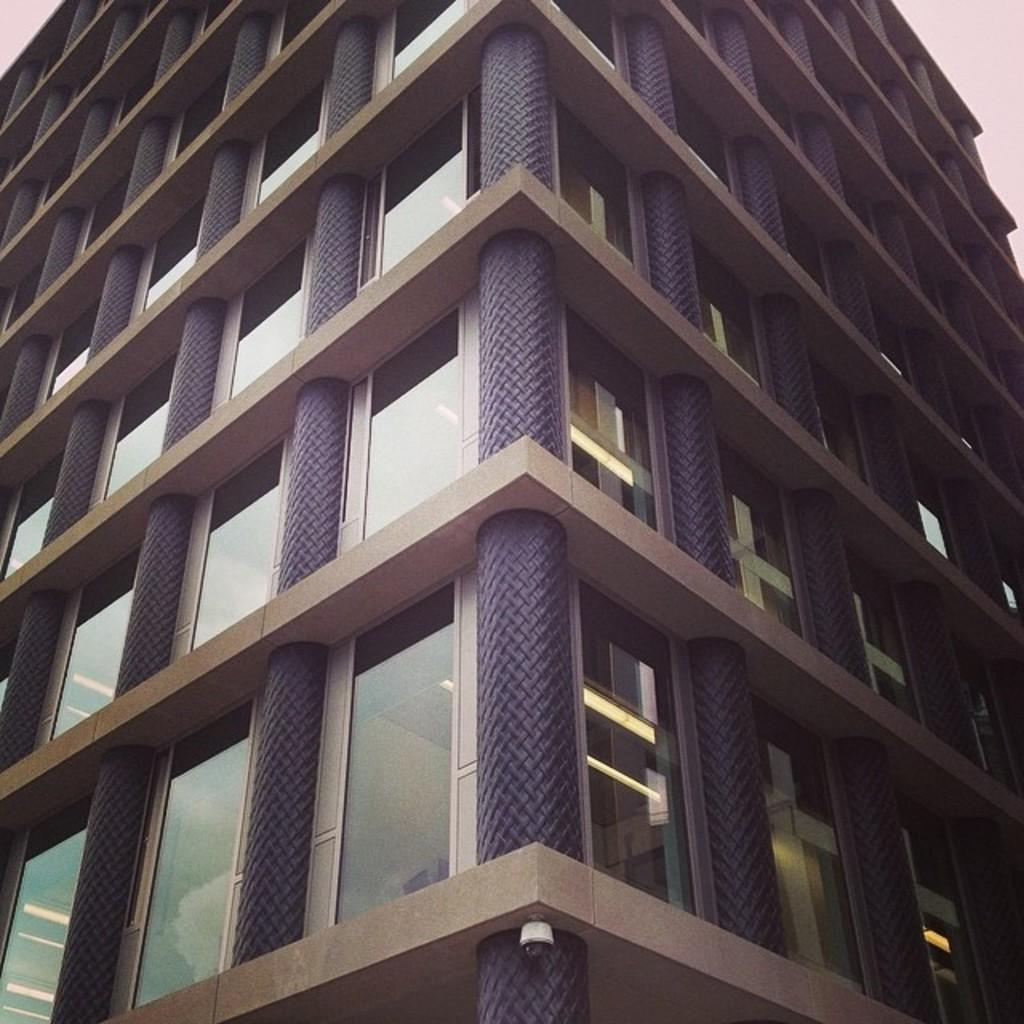What type of structure is present in the image? There is a building in the image. What can be found inside the building? There is a group of glasses visible inside the building. What device is located at the bottom of the image? A camera is visible at the bottom of the image. What part of the natural environment is visible in the image? The sky is visible in the top right corner of the image. What letter does the daughter write to her friend in the image? There is no daughter or letter present in the image. 